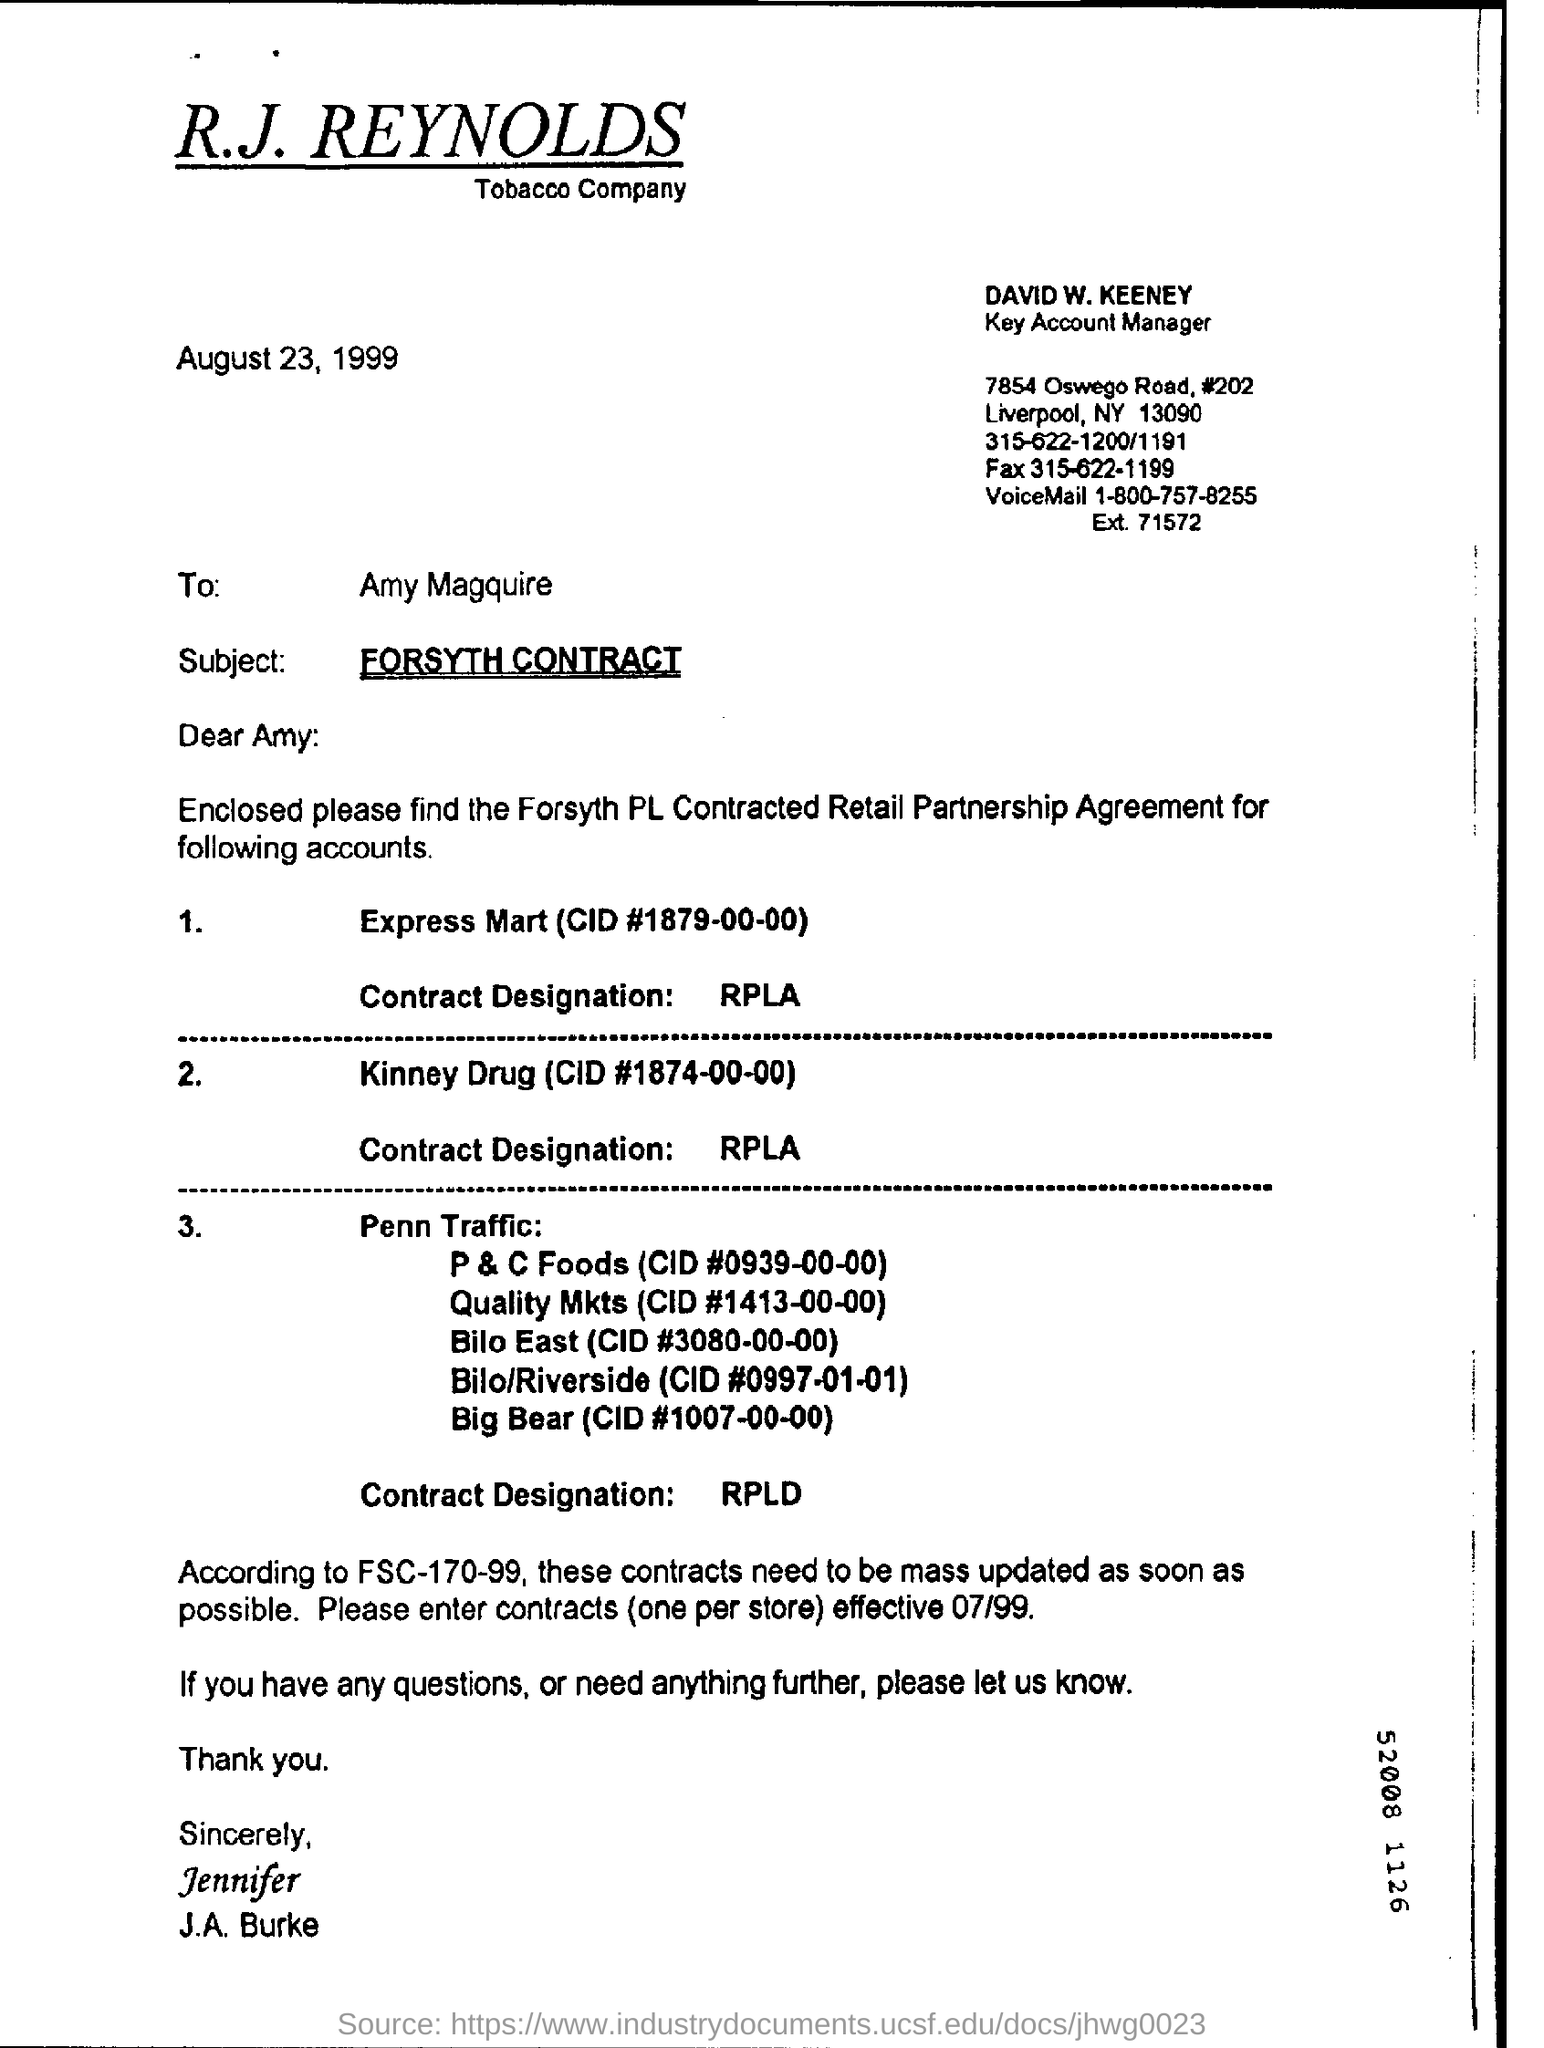Highlight a few significant elements in this photo. The letter is dated August 23, 1999. The contract designation for Express Mart is RPLA. The person's name is David W. Keeney and he is the key account manager. The subject of the letter is Forsyth Contract. 